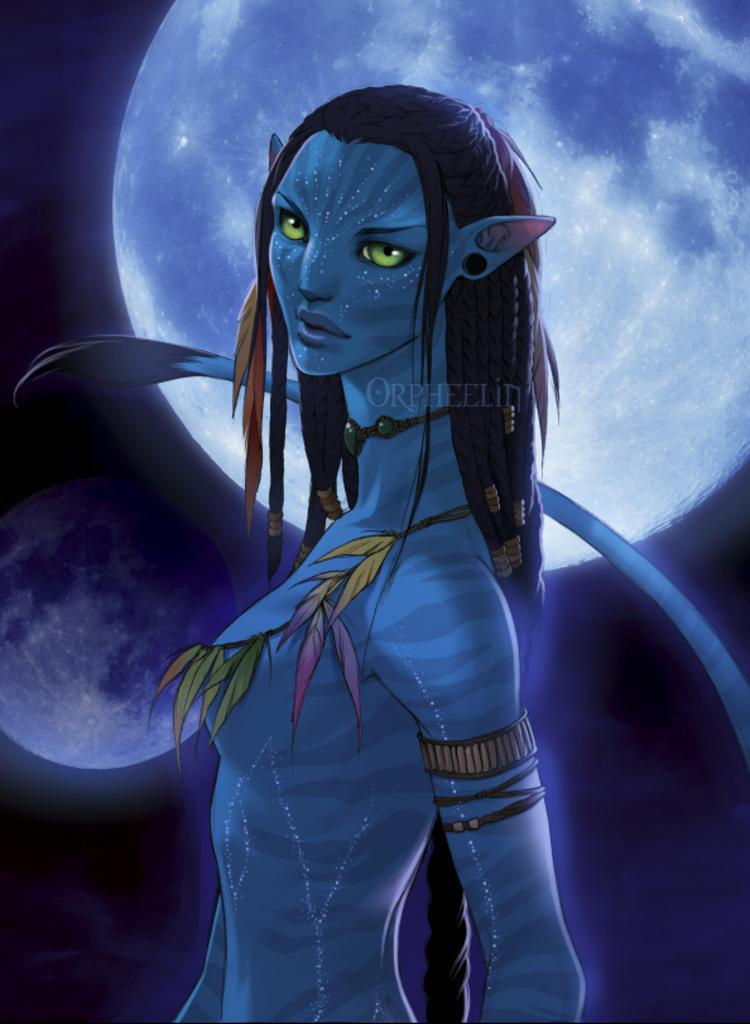What is the main subject of the image? There is an animated image of a woman in the middle of the image. What can be seen in the background of the image? The background of the image includes the moon. What type of trousers is the woman wearing in the image? The image is animated, and there are no trousers visible on the woman. How does the woman's digestion appear to be affected by the moon in the image? The image does not depict the woman's digestion, and there is no indication of its effect from the moon. 